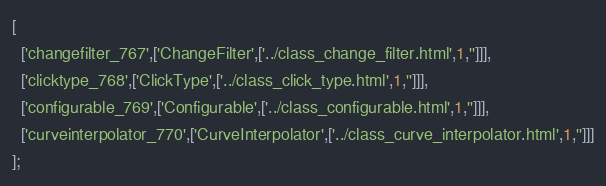Convert code to text. <code><loc_0><loc_0><loc_500><loc_500><_JavaScript_>[
  ['changefilter_767',['ChangeFilter',['../class_change_filter.html',1,'']]],
  ['clicktype_768',['ClickType',['../class_click_type.html',1,'']]],
  ['configurable_769',['Configurable',['../class_configurable.html',1,'']]],
  ['curveinterpolator_770',['CurveInterpolator',['../class_curve_interpolator.html',1,'']]]
];
</code> 